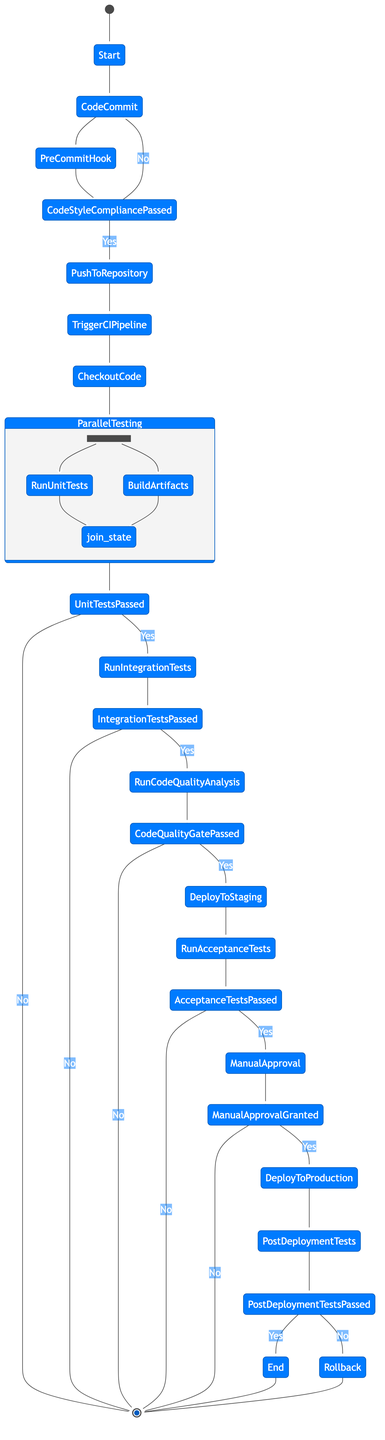What is the first activity in the CI pipeline? The first activity in the CI pipeline is "Code Commit," which signifies the start of the development process where a developer commits code changes to the Git repository.
Answer: Code Commit Which activity directly follows "Push to Repository"? After "Push to Repository," the next activity is "Trigger CI Pipeline," which indicates that the CI process is initiated.
Answer: Trigger CI Pipeline How many decisions are in the diagram? The diagram contains six decision points, each evaluating the results of specific processes within the CI pipeline.
Answer: Six What happens if unit tests do not pass? If unit tests do not pass, the CI pipeline transitions to an end state represented by "*," meaning no further actions are taken.
Answer: End Which activity is performed after "Run Acceptance Tests"? Following "Run Acceptance Tests," the next activity is "Manual Approval," which refers to the necessity for human verification before proceeding.
Answer: Manual Approval What is the purpose of the "Post-Deployment Tests" activity? "Post-Deployment Tests" are conducted to verify the success and stability of the deployment in the production environment.
Answer: Verify deployment success What leads to a rollback in this process? A rollback is triggered if the "Post-Deployment Tests" fail, indicating an issue that requires reverting the last deployment.
Answer: Post-Deployment Tests fail What is the result if "Code Quality Gate Passed?" evaluates negatively? If "Code Quality Gate Passed?" evaluates negatively, the diagram leads to an end state "*," indicating no further actions proceed.
Answer: End Which activities run in parallel during the testing phase? The activities "Run Unit Tests" and "Build Artifacts" execute in parallel during the testing phase, representing an optimization of the CI process.
Answer: Run Unit Tests and Build Artifacts 